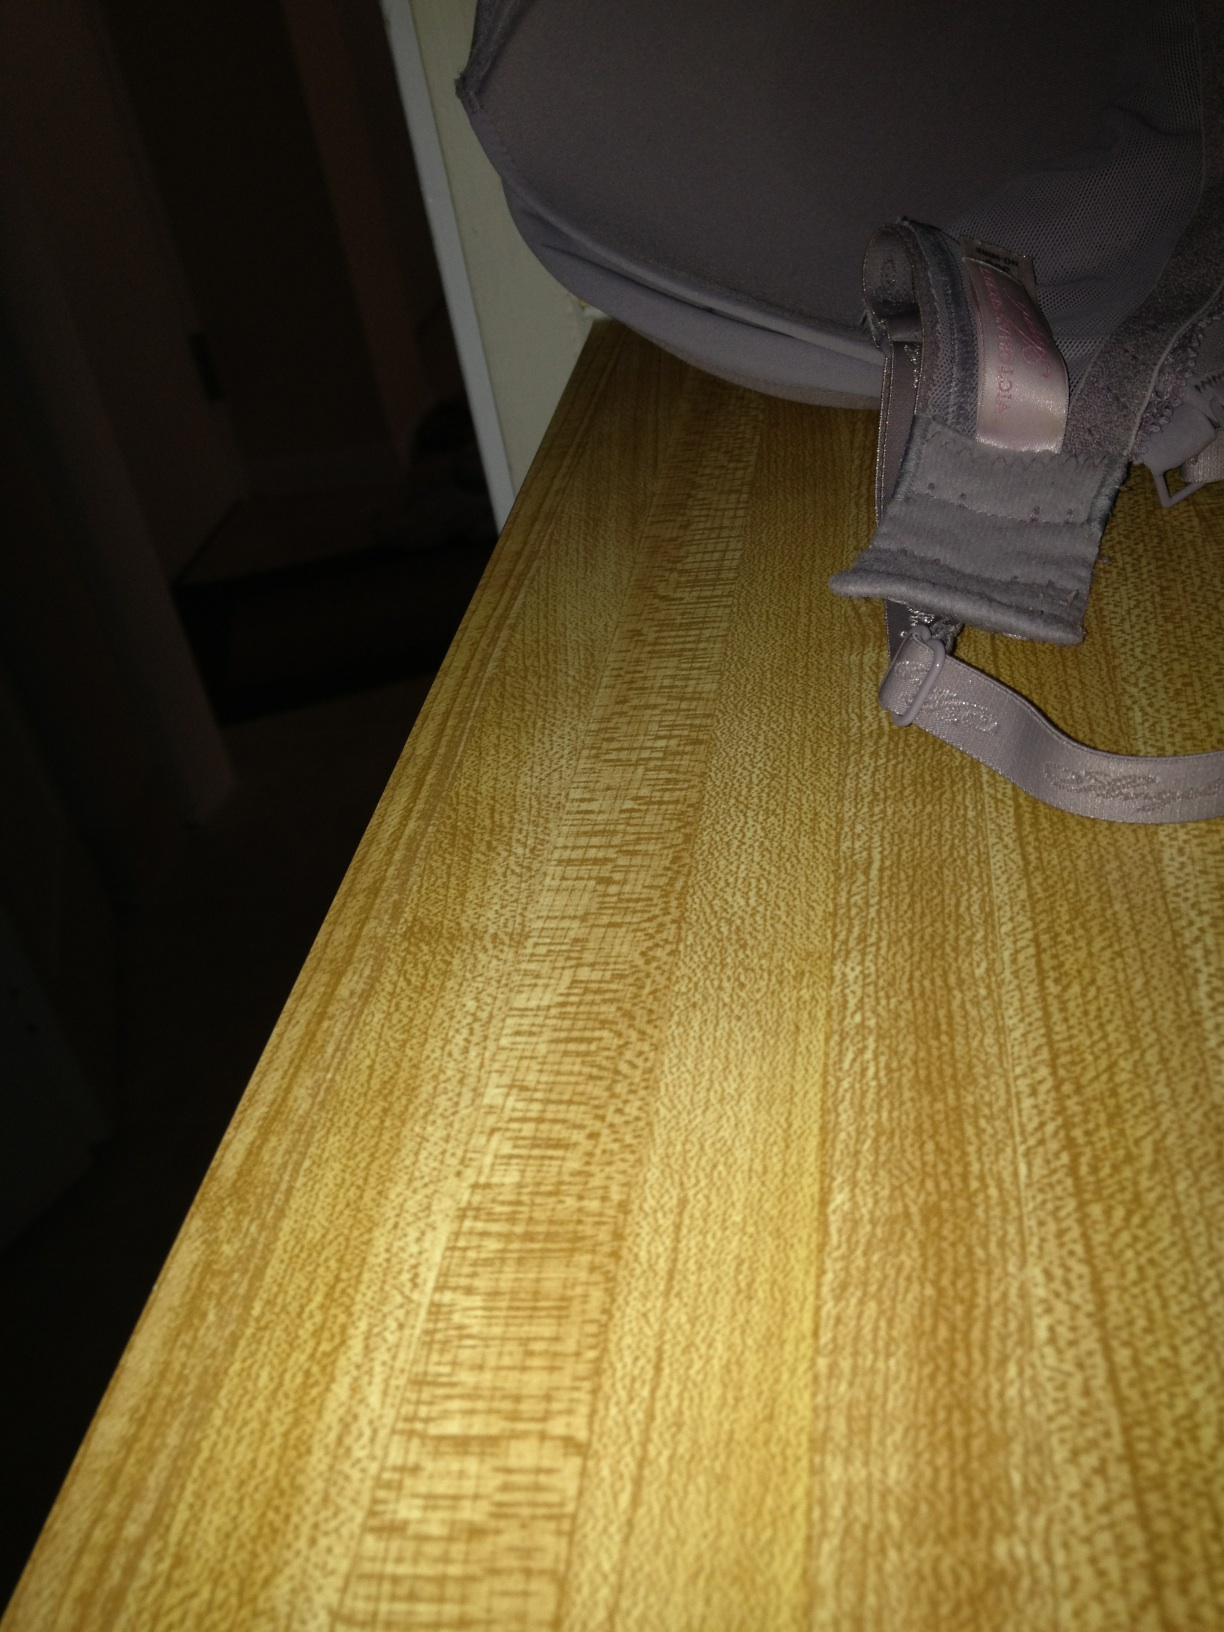How can I tell the size of this undergarment from the image? To determine the size of the undergarment from an image, look for any labels or tags that might list the size. These are usually found attached to the inside of the garment along seams or near the fasteners. 